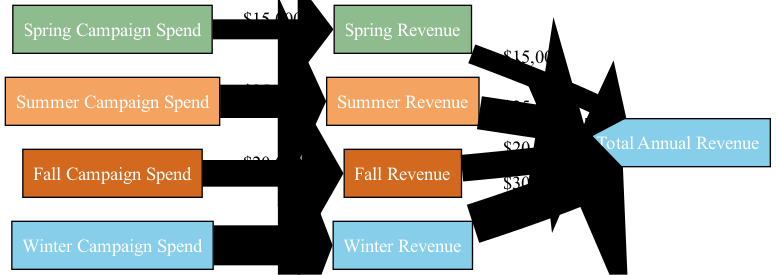What is the total spend across all campaigns? To find the total spend, we sum the campaign spend values. Spring spend is $15,000, Summer spend is $25,000, Fall spend is $20,000, and Winter spend is $30,000. Adding these amounts gives us $15,000 + $25,000 + $20,000 + $30,000 = $90,000.
Answer: 90000 What is the Spring Revenue? The diagram shows the flow from "Spring Campaign Spend" to "Spring Revenue" with a value of $15,000. Therefore, the Spring Revenue is simply the value that flows to it.
Answer: 15000 Which season generated the highest revenue? From the diagram, the revenue values for each season are Spring: $15,000, Summer: $25,000, Fall: $20,000, and Winter: $30,000. The highest value among these is Winter Revenue at $30,000.
Answer: Winter How much did the Summer Campaign Spend contribute to Total Annual Revenue? The Summer Campaign Spend value is $25,000, which flows directly to Summer Revenue. This Summer Revenue also contributes to Total Annual Revenue, thus the contribution is equal to Summer Revenue. Therefore, the answer is $25,000.
Answer: 25000 How many nodes are in the diagram? The diagram consists of the following distinct nodes: "Spring Campaign Spend", "Spring Revenue", "Summer Campaign Spend", "Summer Revenue", "Fall Campaign Spend", "Fall Revenue", "Winter Campaign Spend", "Winter Revenue", and "Total Annual Revenue". Counting these gives us 9 nodes in total.
Answer: 9 What is the revenue-to-spend ratio for the Fall campaign? To calculate the revenue-to-spend ratio for Fall, we take the Fall Revenue of $20,000 and divide it by the Fall Campaign Spend of $20,000. Thus, the ratio is $20,000 / $20,000 = 1.
Answer: 1 Which campaign had the highest spend? The campaign spends are as follows: Spring: $15,000, Summer: $25,000, Fall: $20,000, and Winter: $30,000. Among these, Winter Campaign Spend has the highest value of $30,000.
Answer: Winter What percentage of the Total Annual Revenue is contributed by Winter Revenue? Winter Revenue is $30,000, and the Total Annual Revenue is $100,000 (adding all seasonal revenues: $15,000 from Spring, $25,000 from Summer, $20,000 from Fall, and $30,000 from Winter). Thus, the percentage is calculated as ($30,000 / $100,000) * 100 = 30%.
Answer: 30% What is the sum of the Spring and Fall Revenues? The Spring Revenue is $15,000, and the Fall Revenue is $20,000. Adding these two amounts gives $15,000 + $20,000 = $35,000.
Answer: 35000 